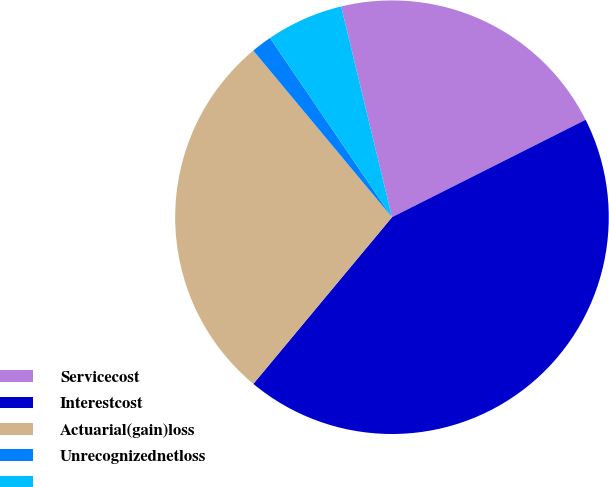<chart> <loc_0><loc_0><loc_500><loc_500><pie_chart><fcel>Servicecost<fcel>Interestcost<fcel>Actuarial(gain)loss<fcel>Unrecognizednetloss<fcel>Unnamed: 4<nl><fcel>21.35%<fcel>43.46%<fcel>27.91%<fcel>1.54%<fcel>5.74%<nl></chart> 